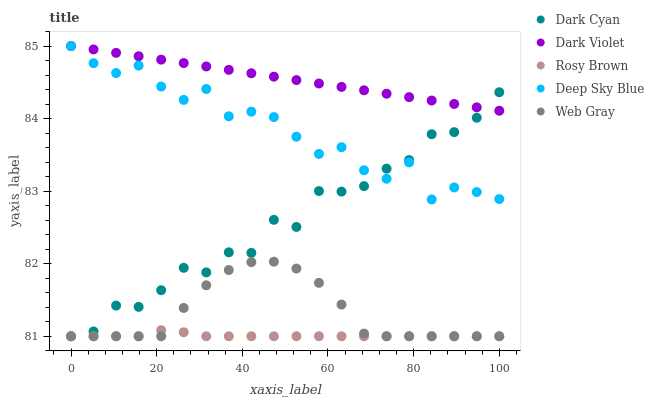Does Rosy Brown have the minimum area under the curve?
Answer yes or no. Yes. Does Dark Violet have the maximum area under the curve?
Answer yes or no. Yes. Does Web Gray have the minimum area under the curve?
Answer yes or no. No. Does Web Gray have the maximum area under the curve?
Answer yes or no. No. Is Dark Violet the smoothest?
Answer yes or no. Yes. Is Deep Sky Blue the roughest?
Answer yes or no. Yes. Is Rosy Brown the smoothest?
Answer yes or no. No. Is Rosy Brown the roughest?
Answer yes or no. No. Does Dark Cyan have the lowest value?
Answer yes or no. Yes. Does Deep Sky Blue have the lowest value?
Answer yes or no. No. Does Dark Violet have the highest value?
Answer yes or no. Yes. Does Web Gray have the highest value?
Answer yes or no. No. Is Rosy Brown less than Dark Violet?
Answer yes or no. Yes. Is Deep Sky Blue greater than Rosy Brown?
Answer yes or no. Yes. Does Web Gray intersect Dark Cyan?
Answer yes or no. Yes. Is Web Gray less than Dark Cyan?
Answer yes or no. No. Is Web Gray greater than Dark Cyan?
Answer yes or no. No. Does Rosy Brown intersect Dark Violet?
Answer yes or no. No. 